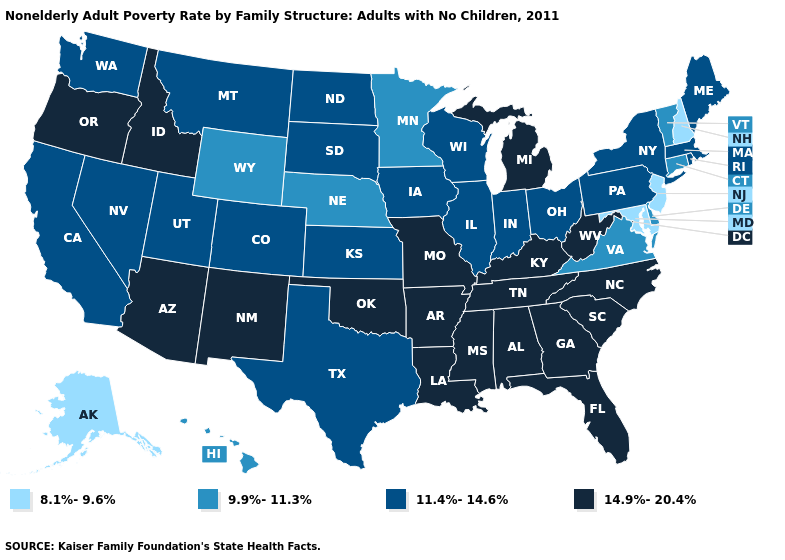What is the value of Pennsylvania?
Be succinct. 11.4%-14.6%. What is the value of New Hampshire?
Be succinct. 8.1%-9.6%. Name the states that have a value in the range 11.4%-14.6%?
Keep it brief. California, Colorado, Illinois, Indiana, Iowa, Kansas, Maine, Massachusetts, Montana, Nevada, New York, North Dakota, Ohio, Pennsylvania, Rhode Island, South Dakota, Texas, Utah, Washington, Wisconsin. Which states have the lowest value in the USA?
Be succinct. Alaska, Maryland, New Hampshire, New Jersey. Name the states that have a value in the range 11.4%-14.6%?
Be succinct. California, Colorado, Illinois, Indiana, Iowa, Kansas, Maine, Massachusetts, Montana, Nevada, New York, North Dakota, Ohio, Pennsylvania, Rhode Island, South Dakota, Texas, Utah, Washington, Wisconsin. Name the states that have a value in the range 8.1%-9.6%?
Write a very short answer. Alaska, Maryland, New Hampshire, New Jersey. What is the highest value in states that border Colorado?
Write a very short answer. 14.9%-20.4%. What is the lowest value in the USA?
Answer briefly. 8.1%-9.6%. What is the highest value in states that border Michigan?
Short answer required. 11.4%-14.6%. Which states have the lowest value in the USA?
Quick response, please. Alaska, Maryland, New Hampshire, New Jersey. Does Oregon have the lowest value in the West?
Answer briefly. No. What is the highest value in the USA?
Quick response, please. 14.9%-20.4%. What is the highest value in states that border California?
Concise answer only. 14.9%-20.4%. What is the value of Michigan?
Be succinct. 14.9%-20.4%. 